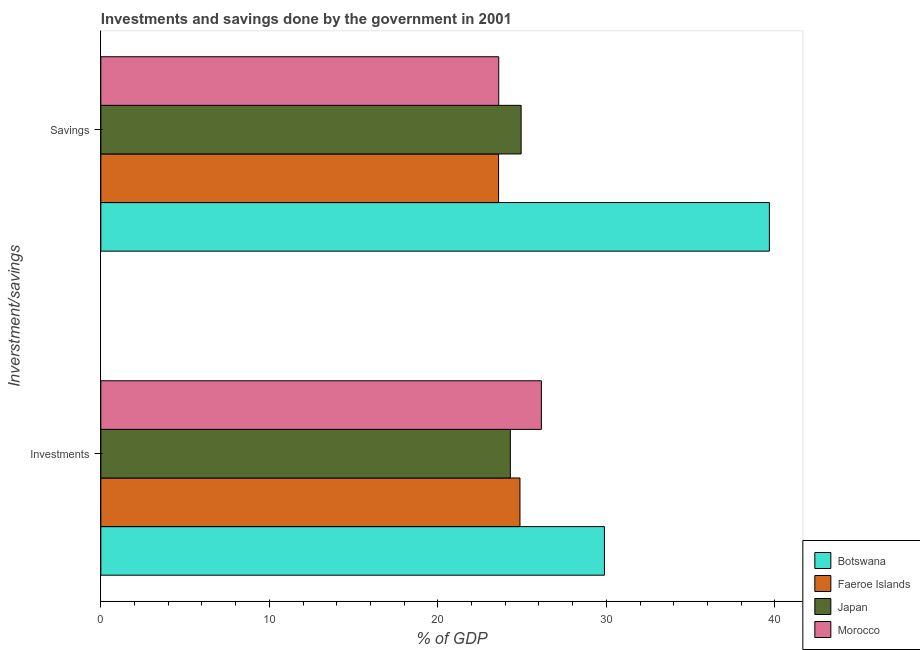Are the number of bars per tick equal to the number of legend labels?
Offer a very short reply. Yes. How many bars are there on the 2nd tick from the top?
Keep it short and to the point. 4. How many bars are there on the 1st tick from the bottom?
Keep it short and to the point. 4. What is the label of the 1st group of bars from the top?
Provide a short and direct response. Savings. What is the savings of government in Morocco?
Offer a very short reply. 23.62. Across all countries, what is the maximum investments of government?
Your response must be concise. 29.89. Across all countries, what is the minimum savings of government?
Your response must be concise. 23.61. In which country was the investments of government maximum?
Offer a terse response. Botswana. What is the total investments of government in the graph?
Make the answer very short. 105.21. What is the difference between the investments of government in Japan and that in Botswana?
Your answer should be compact. -5.58. What is the difference between the savings of government in Botswana and the investments of government in Morocco?
Provide a succinct answer. 13.53. What is the average investments of government per country?
Your response must be concise. 26.3. What is the difference between the investments of government and savings of government in Botswana?
Ensure brevity in your answer.  -9.79. What is the ratio of the investments of government in Morocco to that in Faeroe Islands?
Provide a succinct answer. 1.05. Is the savings of government in Japan less than that in Faeroe Islands?
Your answer should be very brief. No. What does the 3rd bar from the top in Investments represents?
Offer a very short reply. Faeroe Islands. How many bars are there?
Offer a terse response. 8. Are all the bars in the graph horizontal?
Offer a terse response. Yes. Are the values on the major ticks of X-axis written in scientific E-notation?
Ensure brevity in your answer.  No. Does the graph contain grids?
Your response must be concise. No. Where does the legend appear in the graph?
Keep it short and to the point. Bottom right. What is the title of the graph?
Provide a succinct answer. Investments and savings done by the government in 2001. What is the label or title of the X-axis?
Your answer should be compact. % of GDP. What is the label or title of the Y-axis?
Your response must be concise. Inverstment/savings. What is the % of GDP in Botswana in Investments?
Ensure brevity in your answer.  29.89. What is the % of GDP in Faeroe Islands in Investments?
Your answer should be very brief. 24.88. What is the % of GDP in Japan in Investments?
Keep it short and to the point. 24.3. What is the % of GDP in Morocco in Investments?
Provide a short and direct response. 26.15. What is the % of GDP of Botswana in Savings?
Provide a succinct answer. 39.68. What is the % of GDP of Faeroe Islands in Savings?
Give a very brief answer. 23.61. What is the % of GDP in Japan in Savings?
Provide a short and direct response. 24.94. What is the % of GDP of Morocco in Savings?
Make the answer very short. 23.62. Across all Inverstment/savings, what is the maximum % of GDP in Botswana?
Offer a terse response. 39.68. Across all Inverstment/savings, what is the maximum % of GDP in Faeroe Islands?
Make the answer very short. 24.88. Across all Inverstment/savings, what is the maximum % of GDP in Japan?
Your answer should be compact. 24.94. Across all Inverstment/savings, what is the maximum % of GDP in Morocco?
Keep it short and to the point. 26.15. Across all Inverstment/savings, what is the minimum % of GDP of Botswana?
Give a very brief answer. 29.89. Across all Inverstment/savings, what is the minimum % of GDP of Faeroe Islands?
Your answer should be very brief. 23.61. Across all Inverstment/savings, what is the minimum % of GDP in Japan?
Your answer should be very brief. 24.3. Across all Inverstment/savings, what is the minimum % of GDP in Morocco?
Give a very brief answer. 23.62. What is the total % of GDP of Botswana in the graph?
Offer a very short reply. 69.57. What is the total % of GDP in Faeroe Islands in the graph?
Provide a short and direct response. 48.48. What is the total % of GDP in Japan in the graph?
Offer a very short reply. 49.25. What is the total % of GDP of Morocco in the graph?
Offer a terse response. 49.76. What is the difference between the % of GDP in Botswana in Investments and that in Savings?
Keep it short and to the point. -9.79. What is the difference between the % of GDP in Faeroe Islands in Investments and that in Savings?
Offer a very short reply. 1.27. What is the difference between the % of GDP of Japan in Investments and that in Savings?
Give a very brief answer. -0.64. What is the difference between the % of GDP of Morocco in Investments and that in Savings?
Keep it short and to the point. 2.53. What is the difference between the % of GDP of Botswana in Investments and the % of GDP of Faeroe Islands in Savings?
Keep it short and to the point. 6.28. What is the difference between the % of GDP in Botswana in Investments and the % of GDP in Japan in Savings?
Provide a succinct answer. 4.94. What is the difference between the % of GDP in Botswana in Investments and the % of GDP in Morocco in Savings?
Make the answer very short. 6.27. What is the difference between the % of GDP in Faeroe Islands in Investments and the % of GDP in Japan in Savings?
Offer a very short reply. -0.07. What is the difference between the % of GDP of Faeroe Islands in Investments and the % of GDP of Morocco in Savings?
Your answer should be very brief. 1.26. What is the difference between the % of GDP in Japan in Investments and the % of GDP in Morocco in Savings?
Your answer should be compact. 0.69. What is the average % of GDP in Botswana per Inverstment/savings?
Your answer should be compact. 34.78. What is the average % of GDP in Faeroe Islands per Inverstment/savings?
Your answer should be very brief. 24.24. What is the average % of GDP of Japan per Inverstment/savings?
Your answer should be very brief. 24.62. What is the average % of GDP of Morocco per Inverstment/savings?
Your answer should be compact. 24.88. What is the difference between the % of GDP of Botswana and % of GDP of Faeroe Islands in Investments?
Your answer should be compact. 5.01. What is the difference between the % of GDP of Botswana and % of GDP of Japan in Investments?
Keep it short and to the point. 5.58. What is the difference between the % of GDP in Botswana and % of GDP in Morocco in Investments?
Provide a short and direct response. 3.74. What is the difference between the % of GDP of Faeroe Islands and % of GDP of Japan in Investments?
Provide a succinct answer. 0.57. What is the difference between the % of GDP in Faeroe Islands and % of GDP in Morocco in Investments?
Give a very brief answer. -1.27. What is the difference between the % of GDP of Japan and % of GDP of Morocco in Investments?
Your response must be concise. -1.84. What is the difference between the % of GDP in Botswana and % of GDP in Faeroe Islands in Savings?
Ensure brevity in your answer.  16.07. What is the difference between the % of GDP in Botswana and % of GDP in Japan in Savings?
Offer a very short reply. 14.73. What is the difference between the % of GDP of Botswana and % of GDP of Morocco in Savings?
Give a very brief answer. 16.06. What is the difference between the % of GDP in Faeroe Islands and % of GDP in Japan in Savings?
Ensure brevity in your answer.  -1.34. What is the difference between the % of GDP in Faeroe Islands and % of GDP in Morocco in Savings?
Your response must be concise. -0.01. What is the difference between the % of GDP in Japan and % of GDP in Morocco in Savings?
Make the answer very short. 1.33. What is the ratio of the % of GDP in Botswana in Investments to that in Savings?
Your answer should be compact. 0.75. What is the ratio of the % of GDP in Faeroe Islands in Investments to that in Savings?
Your answer should be very brief. 1.05. What is the ratio of the % of GDP of Japan in Investments to that in Savings?
Provide a succinct answer. 0.97. What is the ratio of the % of GDP in Morocco in Investments to that in Savings?
Provide a succinct answer. 1.11. What is the difference between the highest and the second highest % of GDP in Botswana?
Provide a short and direct response. 9.79. What is the difference between the highest and the second highest % of GDP of Faeroe Islands?
Keep it short and to the point. 1.27. What is the difference between the highest and the second highest % of GDP of Japan?
Your answer should be very brief. 0.64. What is the difference between the highest and the second highest % of GDP in Morocco?
Provide a succinct answer. 2.53. What is the difference between the highest and the lowest % of GDP in Botswana?
Keep it short and to the point. 9.79. What is the difference between the highest and the lowest % of GDP of Faeroe Islands?
Ensure brevity in your answer.  1.27. What is the difference between the highest and the lowest % of GDP of Japan?
Give a very brief answer. 0.64. What is the difference between the highest and the lowest % of GDP of Morocco?
Your answer should be very brief. 2.53. 